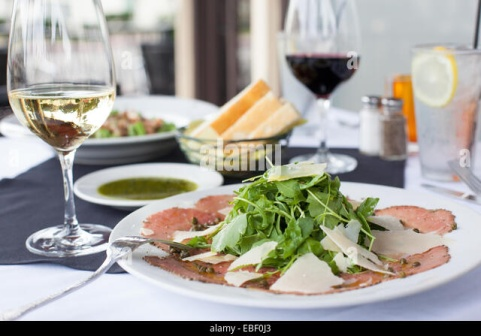What do you think is going on in this snapshot? The image captures a serene moment at a dining table, suggesting a meal set to be enjoyed in a delightful ambiance. At the heart of the scene is a beautifully presented plate of carpaccio, elegantly garnished with fresh arugula and delicate shavings of parmesan cheese. This dish sits invitingly on a black tablecloth, with a fork placed on the left and a knife on the right, ready for someone to savor the meal.

Flanking the main dish, two glasses of wine offer a choice for the diner; one filled with a ruby-red wine, and the other with a crisp white wine, exemplar of a carefully considered pairing to complement the flavors of the carpaccio. To accompany this delectable fare, a small plate of bread sits nearby, accompanied by a dish of olive oil, enhancing the dining experience with simple yet refined touches.

The blurred background hints at a more extensive setting, which could be a patio in a charming restaurant, prompting us to imagine the larger atmosphere that surrounds this intimate dining moment. This image vividly evokes a narrative of enjoyment and culinary delight, inviting the viewer to relish the flavors and textures depicted in the meal. 